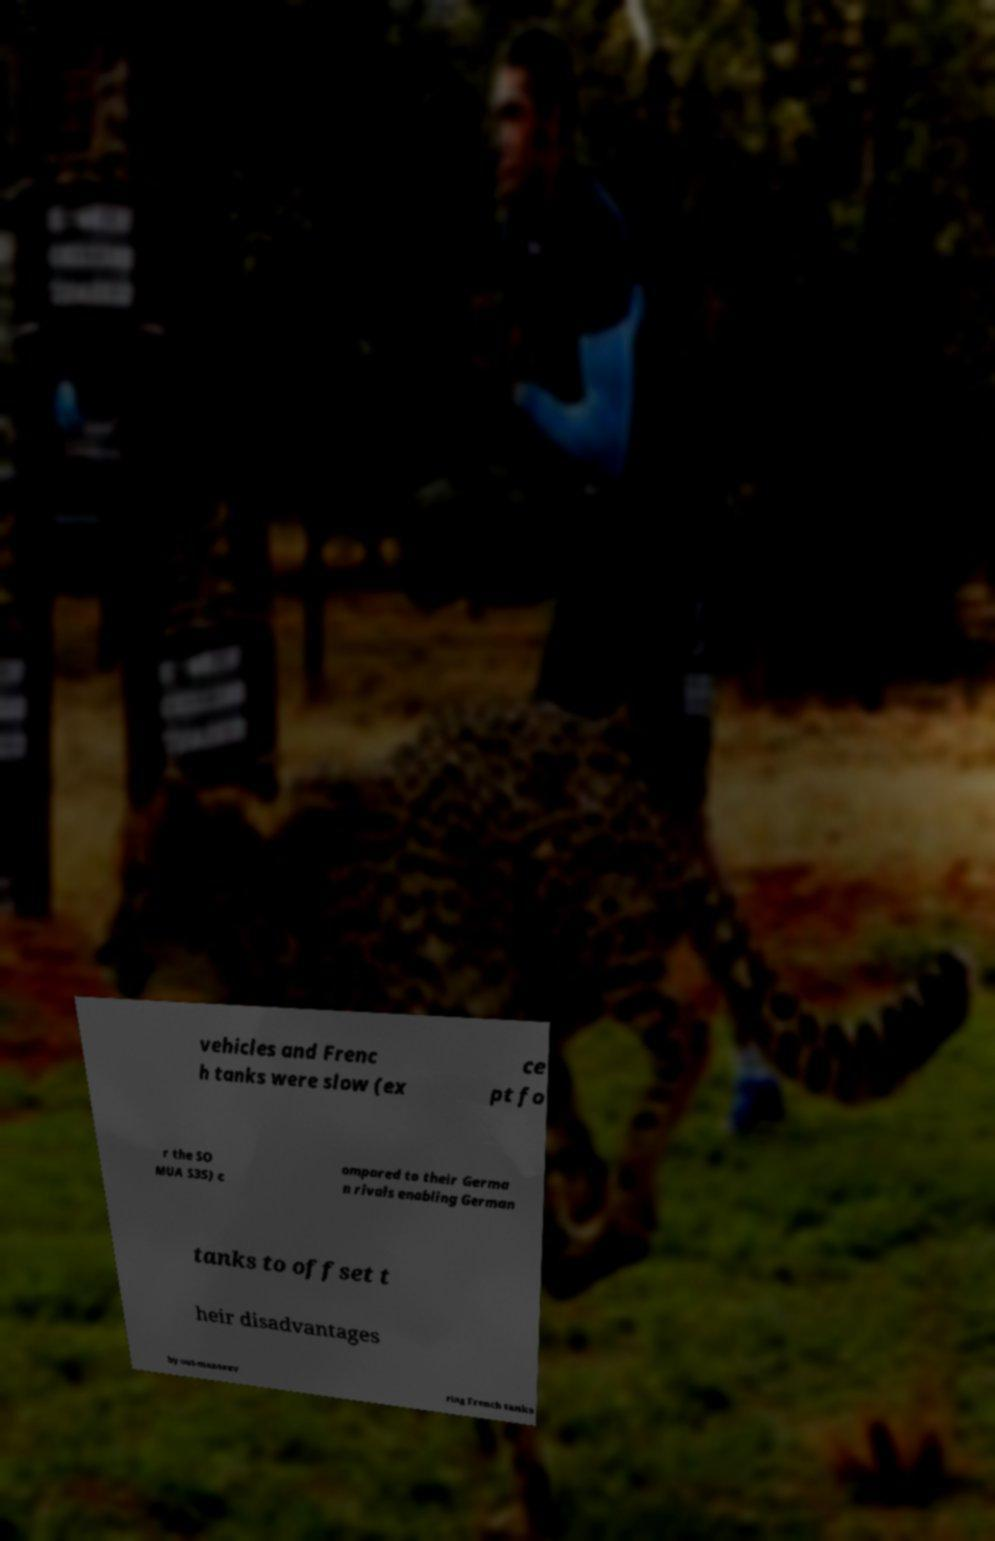Can you read and provide the text displayed in the image?This photo seems to have some interesting text. Can you extract and type it out for me? vehicles and Frenc h tanks were slow (ex ce pt fo r the SO MUA S35) c ompared to their Germa n rivals enabling German tanks to offset t heir disadvantages by out-manoeuv ring French tanks 